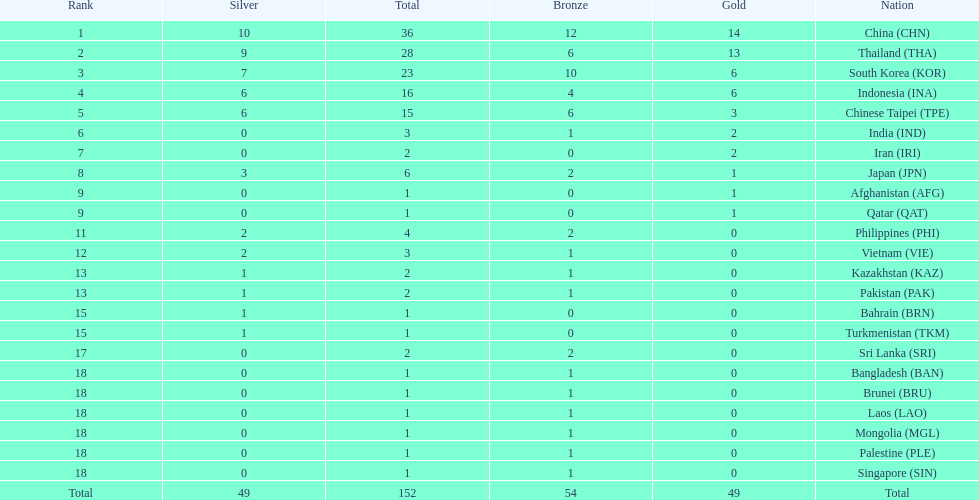What was the number of medals earned by indonesia (ina) ? 16. 